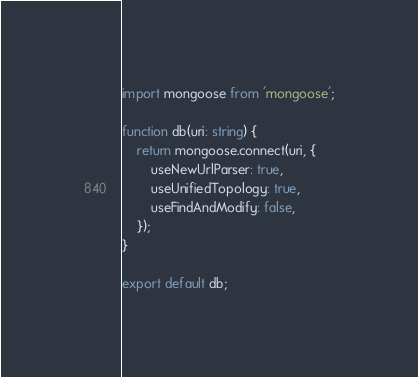<code> <loc_0><loc_0><loc_500><loc_500><_TypeScript_>import mongoose from 'mongoose';

function db(uri: string) {
	return mongoose.connect(uri, {
		useNewUrlParser: true,
		useUnifiedTopology: true,
		useFindAndModify: false,
	});
}

export default db;
</code> 